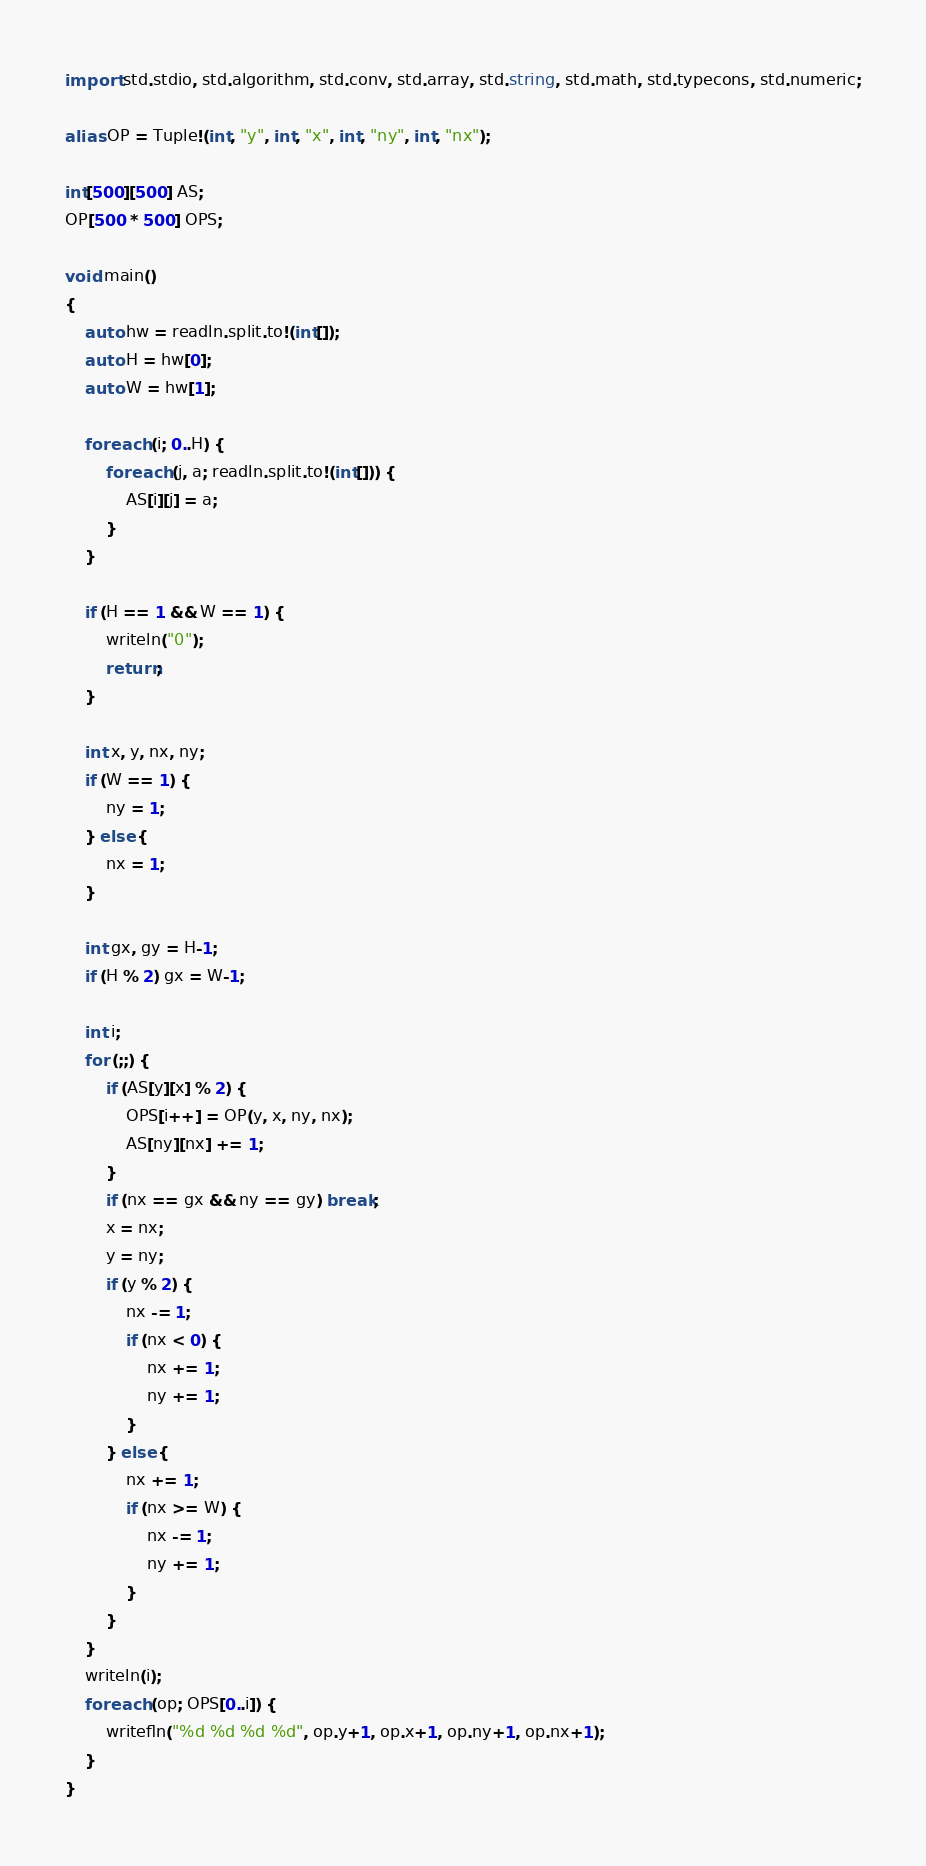Convert code to text. <code><loc_0><loc_0><loc_500><loc_500><_D_>import std.stdio, std.algorithm, std.conv, std.array, std.string, std.math, std.typecons, std.numeric;

alias OP = Tuple!(int, "y", int, "x", int, "ny", int, "nx");

int[500][500] AS;
OP[500 * 500] OPS;

void main()
{
    auto hw = readln.split.to!(int[]);
    auto H = hw[0];
    auto W = hw[1];

    foreach (i; 0..H) {
        foreach (j, a; readln.split.to!(int[])) {
            AS[i][j] = a;
        }
    }

    if (H == 1 && W == 1) {
        writeln("0");
        return;
    }

    int x, y, nx, ny;
    if (W == 1) {
        ny = 1;
    } else {
        nx = 1;
    }

    int gx, gy = H-1;
    if (H % 2) gx = W-1;

    int i;
    for (;;) {
        if (AS[y][x] % 2) {
            OPS[i++] = OP(y, x, ny, nx);
            AS[ny][nx] += 1;
        }
        if (nx == gx && ny == gy) break;
        x = nx;
        y = ny;
        if (y % 2) {
            nx -= 1;
            if (nx < 0) {
                nx += 1;
                ny += 1;
            }
        } else {
            nx += 1;
            if (nx >= W) {
                nx -= 1;
                ny += 1;
            }
        }
    }
    writeln(i);
    foreach (op; OPS[0..i]) {
        writefln("%d %d %d %d", op.y+1, op.x+1, op.ny+1, op.nx+1);
    }
}</code> 